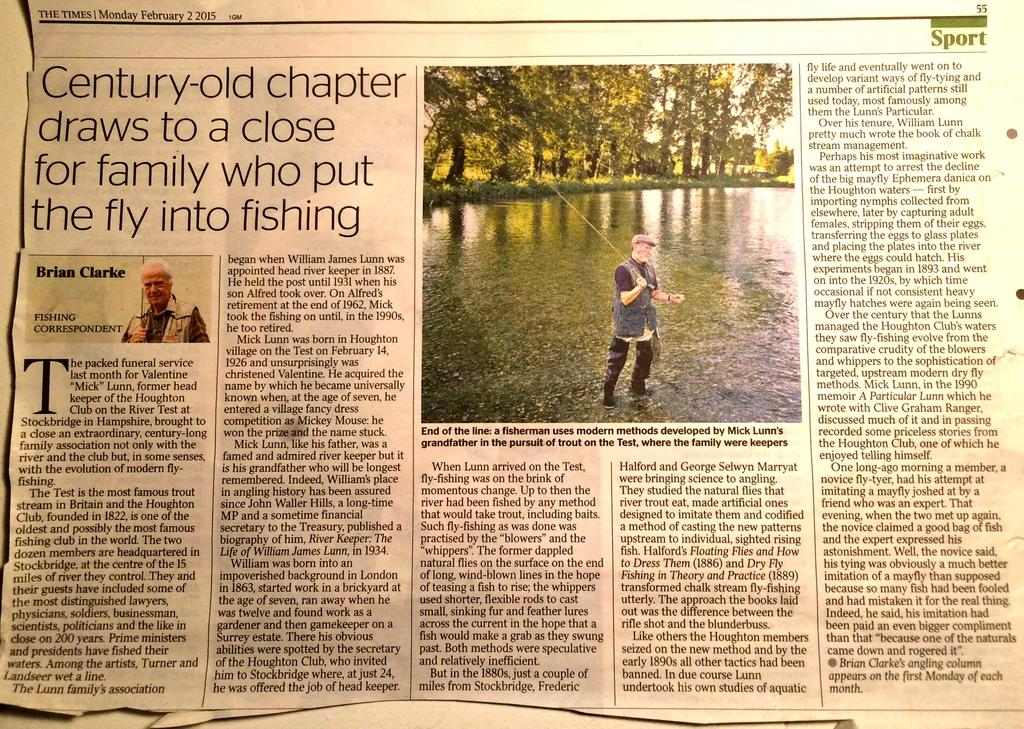What is the main object in the image? There is a newspaper in the image. What can be found on the newspaper? There is a picture on the newspaper. What type of tax is mentioned in the newspaper article? There is no mention of a tax in the image, as it only shows a newspaper with a picture on it. Can you tell me how many kitties are featured in the picture on the newspaper? There is no kitty present in the image; it only shows a newspaper with a picture on it. 